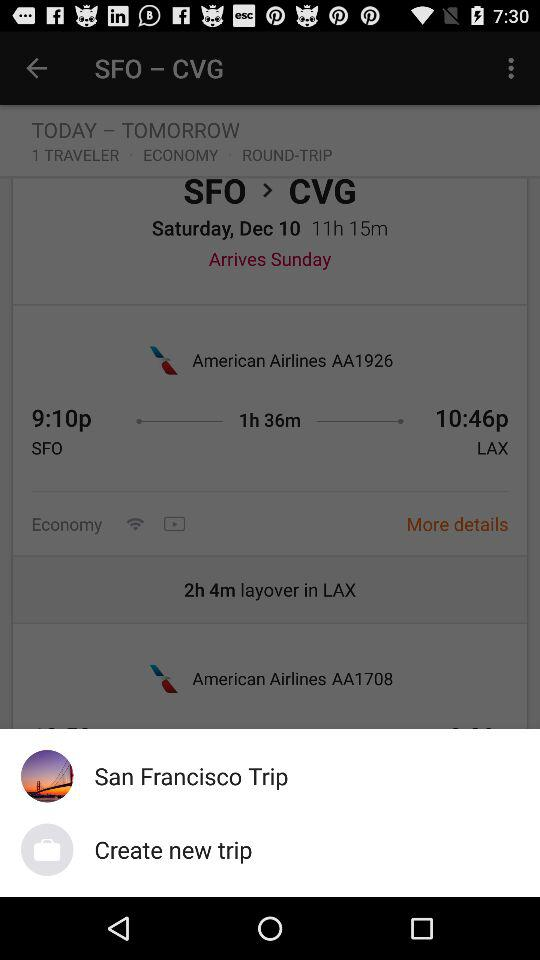For what city is the trip planned? The trip is planned for CVG City. 